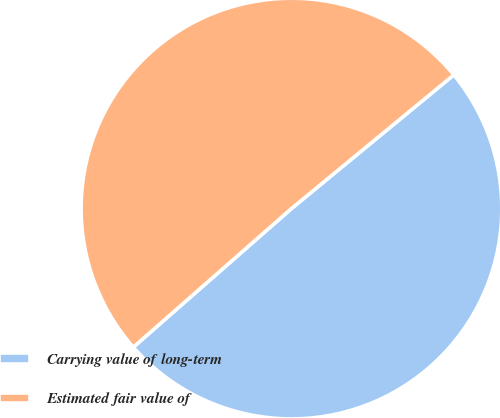<chart> <loc_0><loc_0><loc_500><loc_500><pie_chart><fcel>Carrying value of long-term<fcel>Estimated fair value of<nl><fcel>49.51%<fcel>50.49%<nl></chart> 